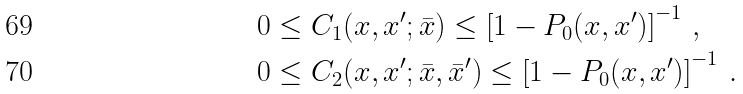<formula> <loc_0><loc_0><loc_500><loc_500>0 & \leq C _ { 1 } ( x , x ^ { \prime } ; \bar { x } ) \leq \left [ 1 - P _ { 0 } ( x , x ^ { \prime } ) \right ] ^ { - 1 } \, , \\ 0 & \leq C _ { 2 } ( x , x ^ { \prime } ; \bar { x } , \bar { x } ^ { \prime } ) \leq \left [ 1 - P _ { 0 } ( x , x ^ { \prime } ) \right ] ^ { - 1 } \, .</formula> 